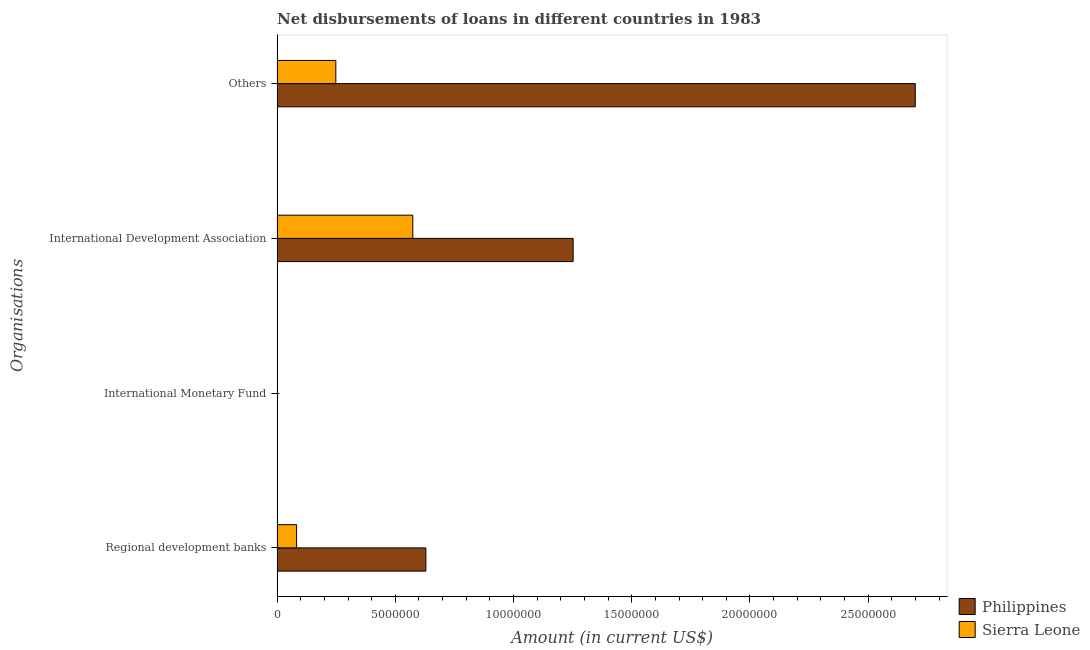How many different coloured bars are there?
Ensure brevity in your answer.  2. Are the number of bars per tick equal to the number of legend labels?
Keep it short and to the point. No. How many bars are there on the 2nd tick from the top?
Your answer should be very brief. 2. How many bars are there on the 3rd tick from the bottom?
Give a very brief answer. 2. What is the label of the 1st group of bars from the top?
Your answer should be compact. Others. What is the amount of loan disimbursed by other organisations in Sierra Leone?
Offer a terse response. 2.48e+06. Across all countries, what is the maximum amount of loan disimbursed by international development association?
Make the answer very short. 1.25e+07. What is the total amount of loan disimbursed by regional development banks in the graph?
Your response must be concise. 7.12e+06. What is the difference between the amount of loan disimbursed by international development association in Sierra Leone and that in Philippines?
Give a very brief answer. -6.78e+06. What is the difference between the amount of loan disimbursed by regional development banks in Philippines and the amount of loan disimbursed by international development association in Sierra Leone?
Offer a very short reply. 5.52e+05. What is the average amount of loan disimbursed by regional development banks per country?
Keep it short and to the point. 3.56e+06. What is the difference between the amount of loan disimbursed by international development association and amount of loan disimbursed by regional development banks in Sierra Leone?
Keep it short and to the point. 4.91e+06. What is the ratio of the amount of loan disimbursed by international development association in Sierra Leone to that in Philippines?
Make the answer very short. 0.46. What is the difference between the highest and the second highest amount of loan disimbursed by regional development banks?
Give a very brief answer. 5.47e+06. What is the difference between the highest and the lowest amount of loan disimbursed by regional development banks?
Give a very brief answer. 5.47e+06. In how many countries, is the amount of loan disimbursed by other organisations greater than the average amount of loan disimbursed by other organisations taken over all countries?
Keep it short and to the point. 1. How many bars are there?
Give a very brief answer. 6. Are all the bars in the graph horizontal?
Your answer should be compact. Yes. How many countries are there in the graph?
Provide a succinct answer. 2. What is the difference between two consecutive major ticks on the X-axis?
Provide a succinct answer. 5.00e+06. Are the values on the major ticks of X-axis written in scientific E-notation?
Provide a short and direct response. No. Does the graph contain any zero values?
Give a very brief answer. Yes. Does the graph contain grids?
Your response must be concise. No. How are the legend labels stacked?
Keep it short and to the point. Vertical. What is the title of the graph?
Give a very brief answer. Net disbursements of loans in different countries in 1983. Does "Mauritius" appear as one of the legend labels in the graph?
Make the answer very short. No. What is the label or title of the Y-axis?
Offer a terse response. Organisations. What is the Amount (in current US$) in Philippines in Regional development banks?
Offer a terse response. 6.29e+06. What is the Amount (in current US$) of Sierra Leone in Regional development banks?
Give a very brief answer. 8.25e+05. What is the Amount (in current US$) of Philippines in International Development Association?
Your answer should be very brief. 1.25e+07. What is the Amount (in current US$) in Sierra Leone in International Development Association?
Make the answer very short. 5.74e+06. What is the Amount (in current US$) of Philippines in Others?
Give a very brief answer. 2.70e+07. What is the Amount (in current US$) in Sierra Leone in Others?
Your response must be concise. 2.48e+06. Across all Organisations, what is the maximum Amount (in current US$) of Philippines?
Give a very brief answer. 2.70e+07. Across all Organisations, what is the maximum Amount (in current US$) of Sierra Leone?
Keep it short and to the point. 5.74e+06. Across all Organisations, what is the minimum Amount (in current US$) of Sierra Leone?
Provide a short and direct response. 0. What is the total Amount (in current US$) of Philippines in the graph?
Provide a short and direct response. 4.58e+07. What is the total Amount (in current US$) in Sierra Leone in the graph?
Make the answer very short. 9.05e+06. What is the difference between the Amount (in current US$) of Philippines in Regional development banks and that in International Development Association?
Make the answer very short. -6.23e+06. What is the difference between the Amount (in current US$) of Sierra Leone in Regional development banks and that in International Development Association?
Your answer should be compact. -4.91e+06. What is the difference between the Amount (in current US$) in Philippines in Regional development banks and that in Others?
Provide a succinct answer. -2.07e+07. What is the difference between the Amount (in current US$) in Sierra Leone in Regional development banks and that in Others?
Offer a very short reply. -1.66e+06. What is the difference between the Amount (in current US$) in Philippines in International Development Association and that in Others?
Keep it short and to the point. -1.45e+07. What is the difference between the Amount (in current US$) of Sierra Leone in International Development Association and that in Others?
Your response must be concise. 3.26e+06. What is the difference between the Amount (in current US$) of Philippines in Regional development banks and the Amount (in current US$) of Sierra Leone in International Development Association?
Keep it short and to the point. 5.52e+05. What is the difference between the Amount (in current US$) of Philippines in Regional development banks and the Amount (in current US$) of Sierra Leone in Others?
Provide a short and direct response. 3.81e+06. What is the difference between the Amount (in current US$) of Philippines in International Development Association and the Amount (in current US$) of Sierra Leone in Others?
Offer a very short reply. 1.00e+07. What is the average Amount (in current US$) of Philippines per Organisations?
Give a very brief answer. 1.15e+07. What is the average Amount (in current US$) in Sierra Leone per Organisations?
Your answer should be compact. 2.26e+06. What is the difference between the Amount (in current US$) of Philippines and Amount (in current US$) of Sierra Leone in Regional development banks?
Keep it short and to the point. 5.47e+06. What is the difference between the Amount (in current US$) in Philippines and Amount (in current US$) in Sierra Leone in International Development Association?
Offer a very short reply. 6.78e+06. What is the difference between the Amount (in current US$) in Philippines and Amount (in current US$) in Sierra Leone in Others?
Ensure brevity in your answer.  2.45e+07. What is the ratio of the Amount (in current US$) in Philippines in Regional development banks to that in International Development Association?
Provide a short and direct response. 0.5. What is the ratio of the Amount (in current US$) in Sierra Leone in Regional development banks to that in International Development Association?
Your answer should be very brief. 0.14. What is the ratio of the Amount (in current US$) in Philippines in Regional development banks to that in Others?
Your response must be concise. 0.23. What is the ratio of the Amount (in current US$) in Sierra Leone in Regional development banks to that in Others?
Keep it short and to the point. 0.33. What is the ratio of the Amount (in current US$) of Philippines in International Development Association to that in Others?
Your answer should be very brief. 0.46. What is the ratio of the Amount (in current US$) in Sierra Leone in International Development Association to that in Others?
Your response must be concise. 2.31. What is the difference between the highest and the second highest Amount (in current US$) of Philippines?
Make the answer very short. 1.45e+07. What is the difference between the highest and the second highest Amount (in current US$) of Sierra Leone?
Offer a terse response. 3.26e+06. What is the difference between the highest and the lowest Amount (in current US$) of Philippines?
Offer a very short reply. 2.70e+07. What is the difference between the highest and the lowest Amount (in current US$) in Sierra Leone?
Offer a terse response. 5.74e+06. 